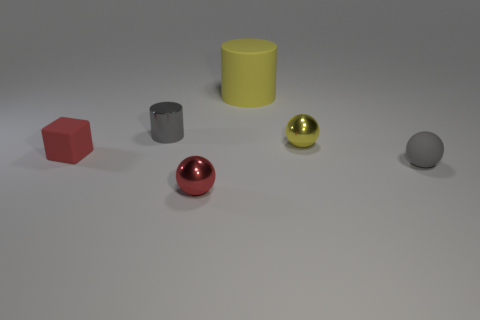Is the shape of the tiny matte object that is left of the gray matte object the same as  the tiny gray matte object?
Your answer should be compact. No. Is the number of small gray things behind the small block less than the number of yellow objects?
Your response must be concise. Yes. Is there a yellow cylinder that has the same material as the small cube?
Make the answer very short. Yes. There is a red block that is the same size as the gray metal cylinder; what is it made of?
Offer a terse response. Rubber. Are there fewer tiny red rubber blocks that are behind the block than small yellow objects in front of the red metallic ball?
Your answer should be compact. No. The rubber thing that is to the right of the small cube and in front of the yellow sphere has what shape?
Provide a short and direct response. Sphere. What number of other yellow shiny objects are the same shape as the large object?
Offer a terse response. 0. There is a gray sphere that is made of the same material as the tiny cube; what size is it?
Give a very brief answer. Small. Is the number of tiny cubes greater than the number of red objects?
Your answer should be very brief. No. The rubber thing to the left of the small red shiny object is what color?
Provide a short and direct response. Red. 